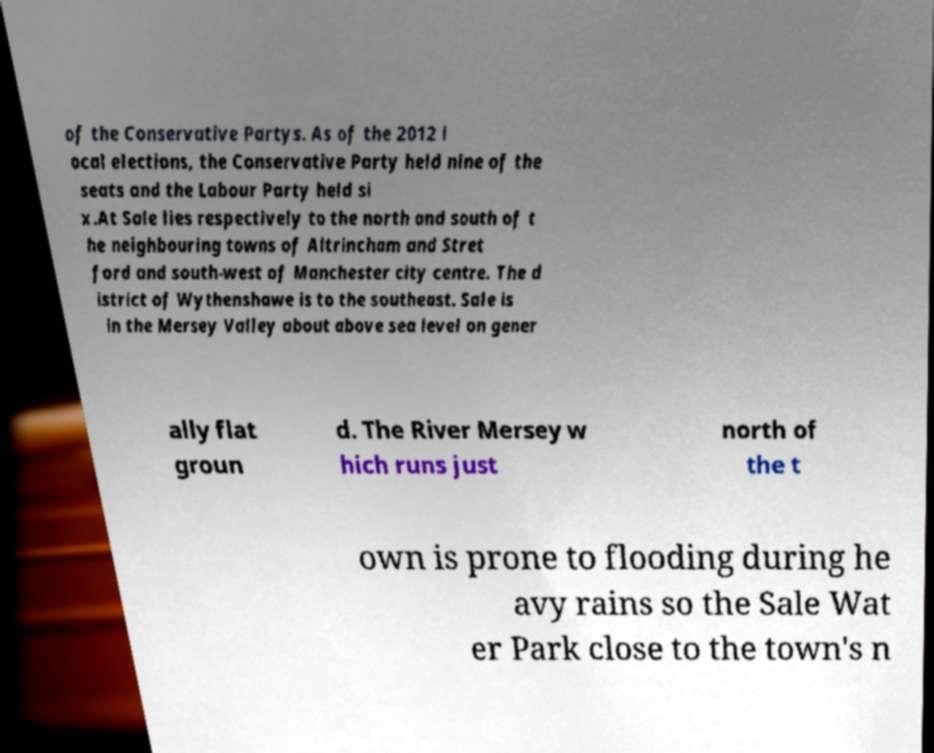Could you extract and type out the text from this image? of the Conservative Partys. As of the 2012 l ocal elections, the Conservative Party held nine of the seats and the Labour Party held si x.At Sale lies respectively to the north and south of t he neighbouring towns of Altrincham and Stret ford and south-west of Manchester city centre. The d istrict of Wythenshawe is to the southeast. Sale is in the Mersey Valley about above sea level on gener ally flat groun d. The River Mersey w hich runs just north of the t own is prone to flooding during he avy rains so the Sale Wat er Park close to the town's n 